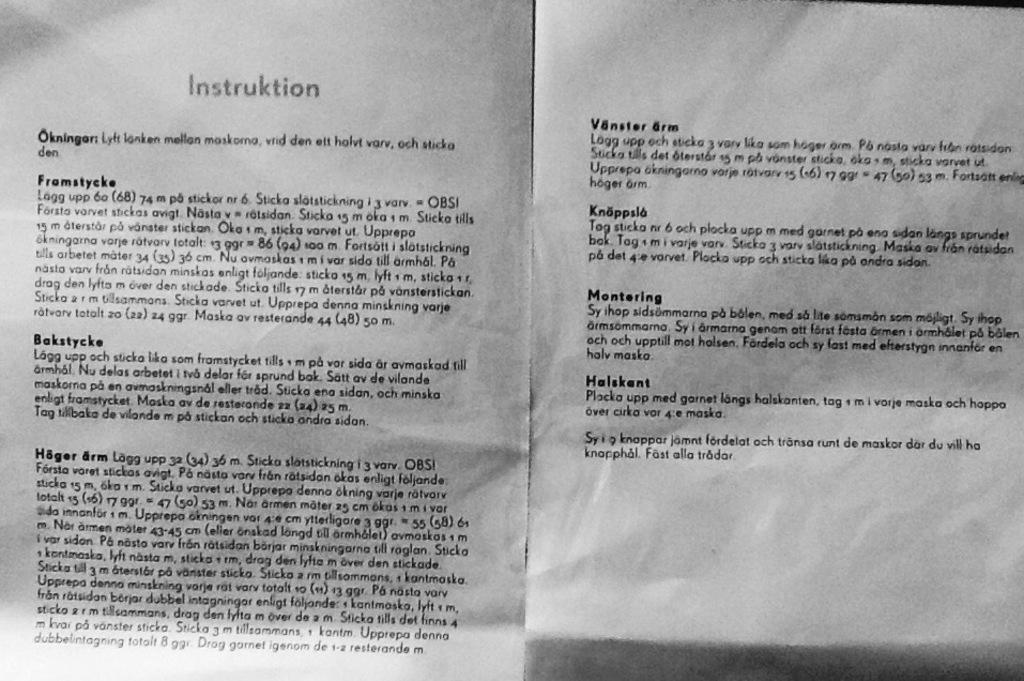What's the title of the sheet?
Provide a succinct answer. Instruktion. What is the first word on the paper?
Your response must be concise. Instruktion. 